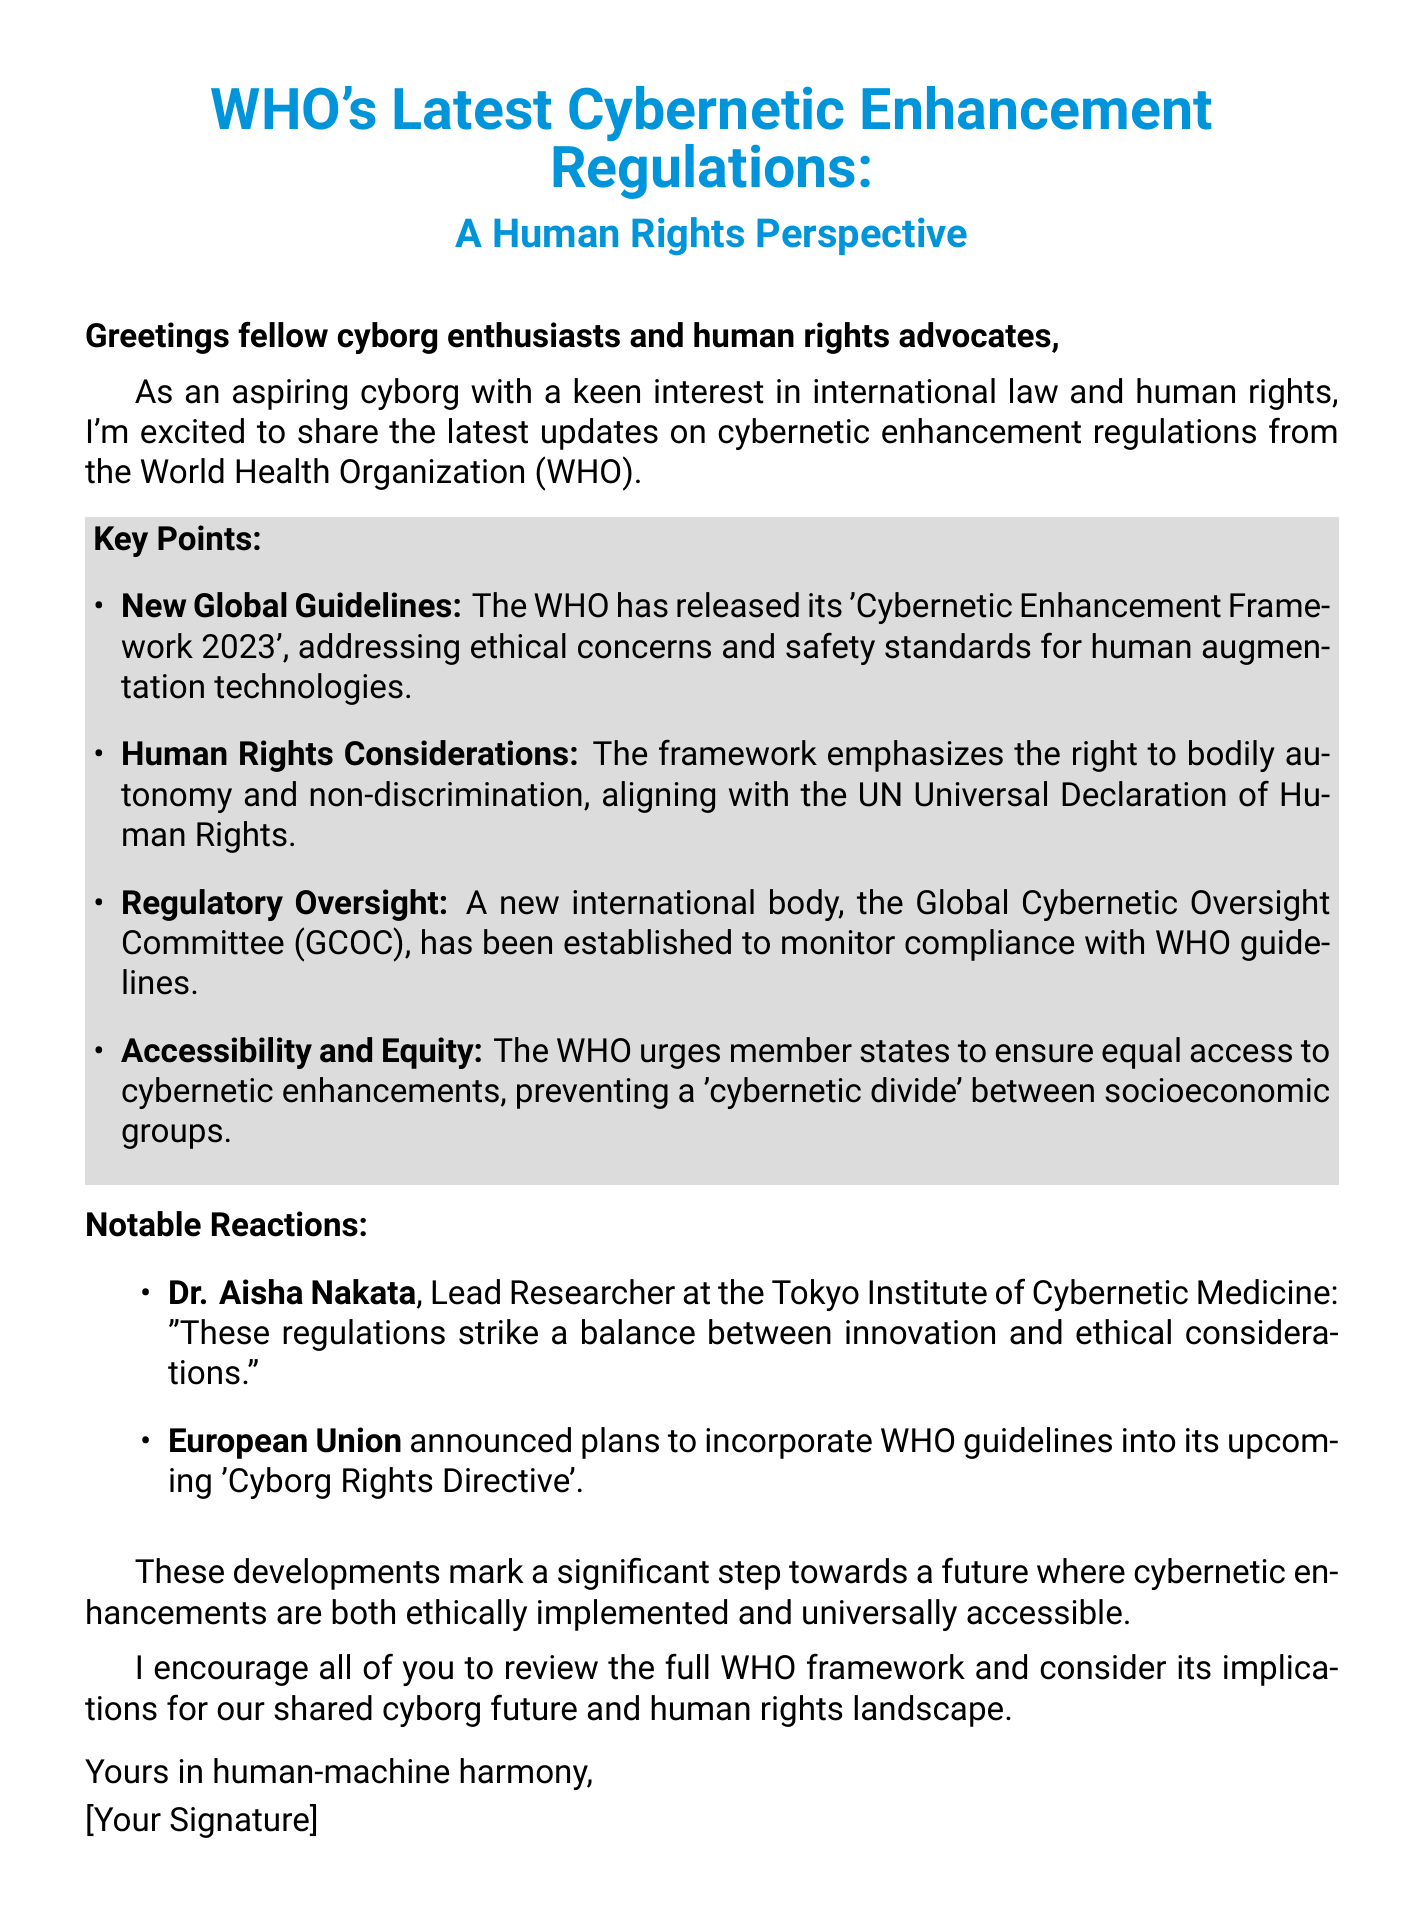What is the title of the WHO's new framework? The title of the new framework is 'Cybernetic Enhancement Framework 2023'.
Answer: 'Cybernetic Enhancement Framework 2023' What is the main human rights consideration emphasized in the framework? The main human rights consideration is the right to bodily autonomy and non-discrimination.
Answer: right to bodily autonomy and non-discrimination What committee has been established to monitor compliance with WHO guidelines? The new committee established is the Global Cybernetic Oversight Committee (GCOC).
Answer: Global Cybernetic Oversight Committee (GCOC) What does the WHO urge member states to ensure regarding cybernetic enhancements? The WHO urges member states to ensure equal access to cybernetic enhancements.
Answer: equal access to cybernetic enhancements Who is the Lead Researcher at the Tokyo Institute of Cybernetic Medicine? The Lead Researcher is Dr. Aisha Nakata.
Answer: Dr. Aisha Nakata What significant directive is the European Union planning to incorporate WHO guidelines into? The directive is the 'Cyborg Rights Directive'.
Answer: 'Cyborg Rights Directive' What overarching goal do the developments in the document aim for? The goal is to achieve a future where cybernetic enhancements are ethically implemented and universally accessible.
Answer: ethically implemented and universally accessible What is the greeting in the email? The greeting is "Greetings fellow cyborg enthusiasts and human rights advocates,".
Answer: Greetings fellow cyborg enthusiasts and human rights advocates, What type of document is this content derived from? This content is derived from an email.
Answer: email 